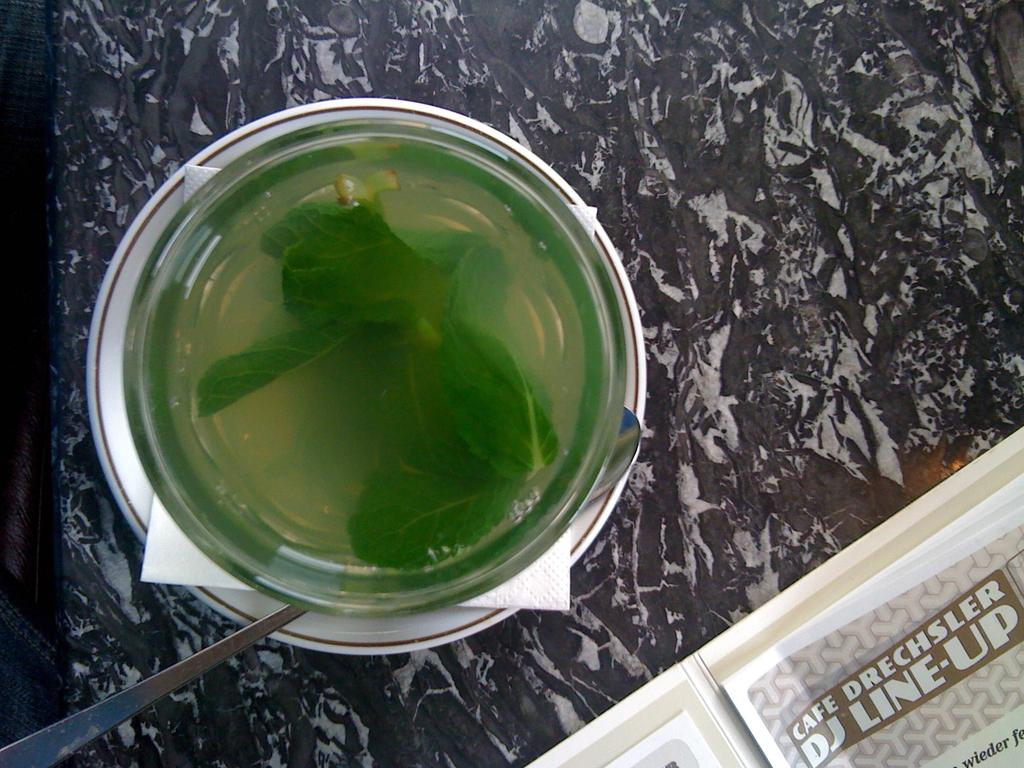What is inside the glass that is visible in the image? There are mint leaves in the glass. What utensil is present in the image? There is a spoon in the image. What is on the table in the image? There is a paper on the table in the image. How many pies are on the table in the image? There are no pies present in the image. What type of cup is being used to hold the mint leaves? There is no cup mentioned in the image; it is a glass that holds the mint leaves. 